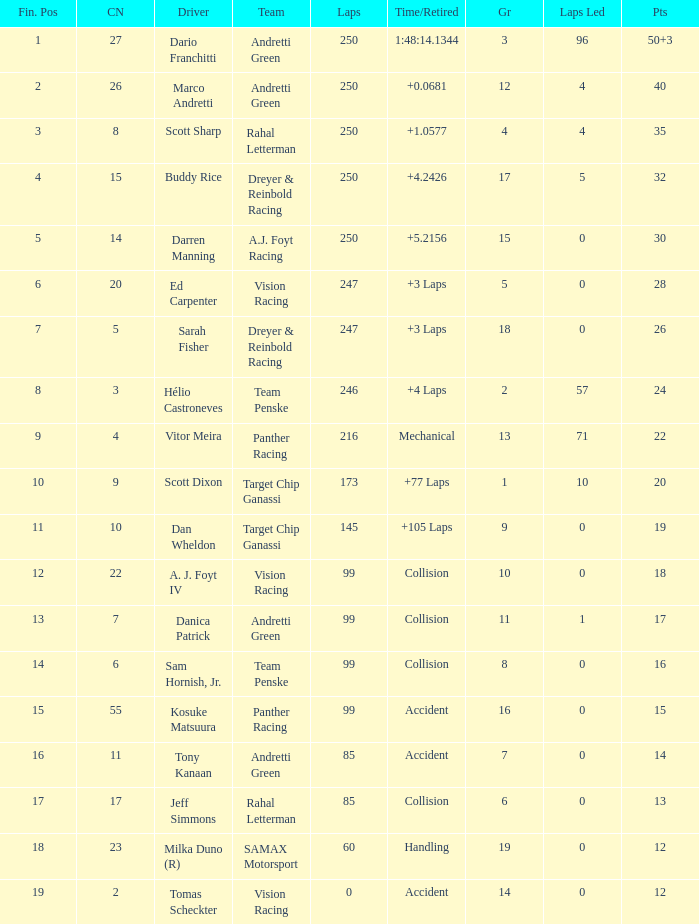What is the grid for the driver who earned 14 points? 7.0. 